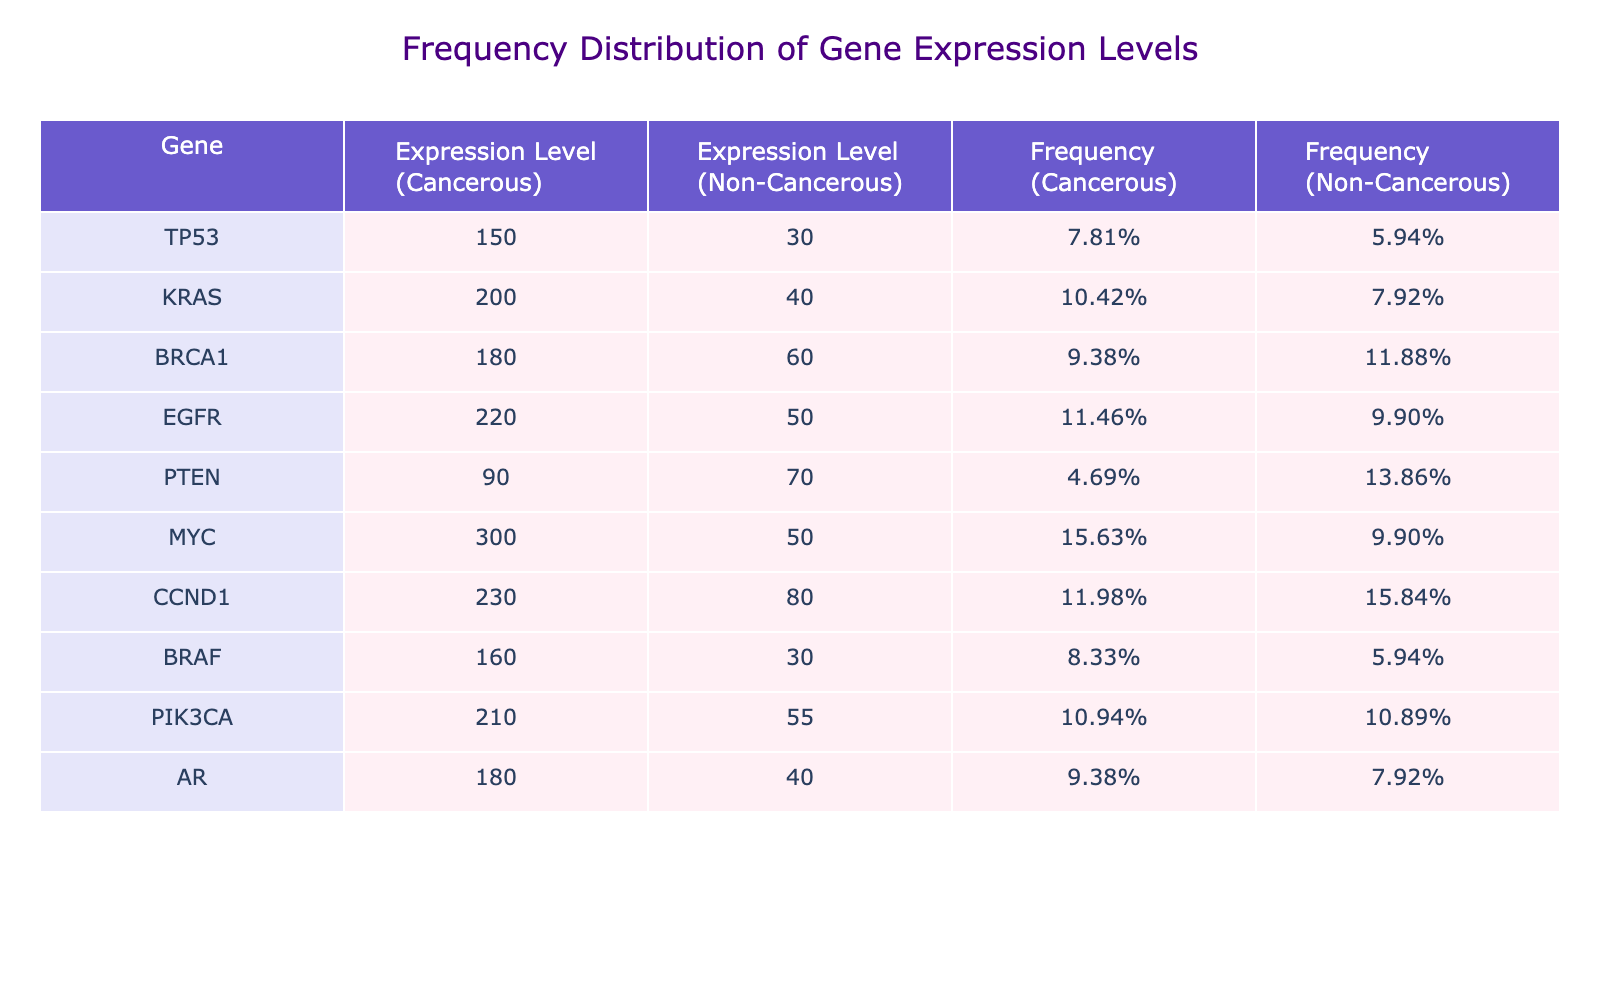What is the expression level of the gene MYC in cancerous tissues? The table shows that the expression level for the gene MYC in cancerous tissues is clearly stated as 300.
Answer: 300 What is the frequency of expression level for the gene KRAS in non-cancerous tissues? By checking the frequency column in the table, the frequency of KRAS in non-cancerous tissues is calculated as the expression level divided by the total expression level for non-cancerous tissues. The value listed in the table is 0.17, or 17%.
Answer: 0.17 Which gene has the highest expression level in non-cancerous tissues? The expression levels in non-cancerous tissues for each gene are compared. PTEN has the highest value at 70, which is more than any other gene listed.
Answer: PTEN What is the total expression level for all cancerous genes? The expression levels of all cancerous genes are added together: 150 (TP53) + 200 (KRAS) + 180 (BRCA1) + 220 (EGFR) + 90 (PTEN) + 300 (MYC) + 230 (CCND1) + 160 (BRAF) + 210 (PIK3CA) + 180 (AR) = 1860.
Answer: 1860 Is the expression level of EGFR in cancerous tissues greater than that of PIK3CA in non-cancerous tissues? The expression level of EGFR in cancerous tissues is 220, while that of PIK3CA in non-cancerous tissues is 55. Since 220 is greater than 55, the statement is true.
Answer: Yes What is the difference in expression levels between MYC in cancerous tissues and BRCA1 in non-cancerous tissues? The expression level of MYC in cancerous tissues is 300, and BRCA1 in non-cancerous tissues is 60. The difference is calculated as 300 - 60 = 240.
Answer: 240 Which gene shows a lower frequency of expression in cancerous tissues, AR or BRAF? The frequencies from the table are compared: AR has a frequency of 0.17 and BRAF has a frequency of 0.10. Since 0.10 is lower than 0.17, BRAF shows a lower frequency in cancerous tissues.
Answer: BRAF What is the average expression level of all genes in non-cancerous tissues? To find the average expression level in non-cancerous tissues, you sum up all the values: 30 (TP53) + 40 (KRAS) + 60 (BRCA1) + 50 (EGFR) + 70 (PTEN) + 50 (MYC) + 80 (CCND1) + 30 (BRAF) + 55 (PIK3CA) + 40 (AR) = 505. Then divide by the number of genes, which is 10: 505 / 10 = 50.5.
Answer: 50.5 How many genes have an expression level greater than 200 in cancerous tissues? Each gene's expression level in cancerous tissues is evaluated. TP53 (150), KRAS (200), BRCA1 (180), EGFR (220), PTEN (90), MYC (300), CCND1 (230), BRAF (160), PIK3CA (210), and AR (180). Counting the genes that exceed 200, we find 4 genes: EGFR, MYC, CCND1, and PIK3CA.
Answer: 4 